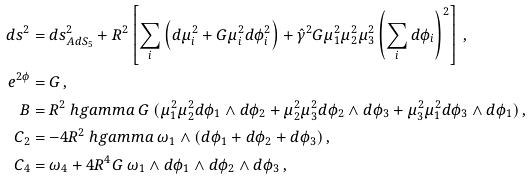<formula> <loc_0><loc_0><loc_500><loc_500>d s ^ { 2 } & = d s ^ { 2 } _ { A d S _ { 5 } } + R ^ { 2 } \left [ \sum _ { i } \left ( d \mu _ { i } ^ { 2 } + G \mu _ { i } ^ { 2 } d \phi _ { i } ^ { 2 } \right ) + \hat { \gamma } ^ { 2 } G \mu _ { 1 } ^ { 2 } \mu _ { 2 } ^ { 2 } \mu _ { 3 } ^ { 2 } \left ( \sum _ { i } d \phi _ { i } \right ) ^ { 2 } \right ] \, , \\ e ^ { 2 \phi } & = G \, , \\ B & = R ^ { 2 } \ h g a m m a \ G \ ( \mu _ { 1 } ^ { 2 } \mu _ { 2 } ^ { 2 } d \phi _ { 1 } \wedge d \phi _ { 2 } + \mu _ { 2 } ^ { 2 } \mu _ { 3 } ^ { 2 } d \phi _ { 2 } \wedge d \phi _ { 3 } + \mu _ { 3 } ^ { 2 } \mu _ { 1 } ^ { 2 } d \phi _ { 3 } \wedge d \phi _ { 1 } ) \, , \\ C _ { 2 } & = - 4 R ^ { 2 } \ h g a m m a \ \omega _ { 1 } \wedge ( d \phi _ { 1 } + d \phi _ { 2 } + d \phi _ { 3 } ) \, , \\ C _ { 4 } & = \omega _ { 4 } + 4 R ^ { 4 } G \ \omega _ { 1 } \wedge d \phi _ { 1 } \wedge d \phi _ { 2 } \wedge d \phi _ { 3 } \, ,</formula> 